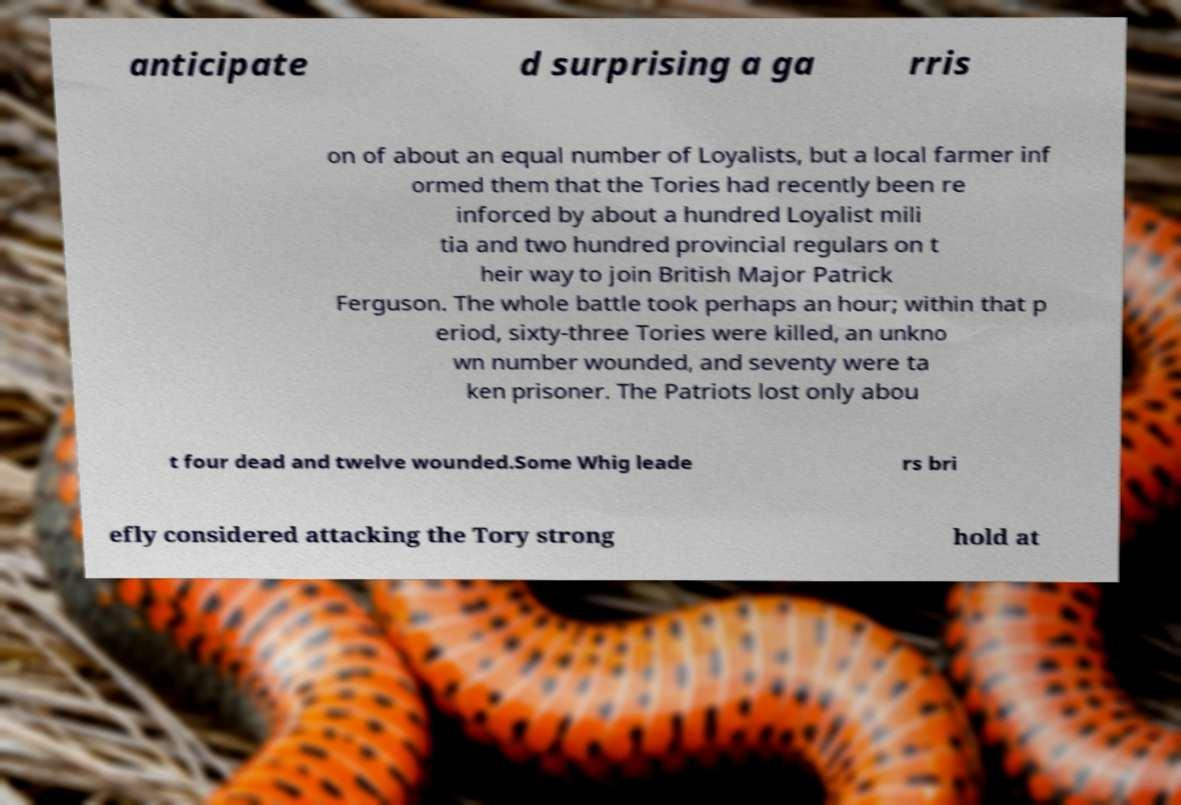Can you accurately transcribe the text from the provided image for me? anticipate d surprising a ga rris on of about an equal number of Loyalists, but a local farmer inf ormed them that the Tories had recently been re inforced by about a hundred Loyalist mili tia and two hundred provincial regulars on t heir way to join British Major Patrick Ferguson. The whole battle took perhaps an hour; within that p eriod, sixty-three Tories were killed, an unkno wn number wounded, and seventy were ta ken prisoner. The Patriots lost only abou t four dead and twelve wounded.Some Whig leade rs bri efly considered attacking the Tory strong hold at 